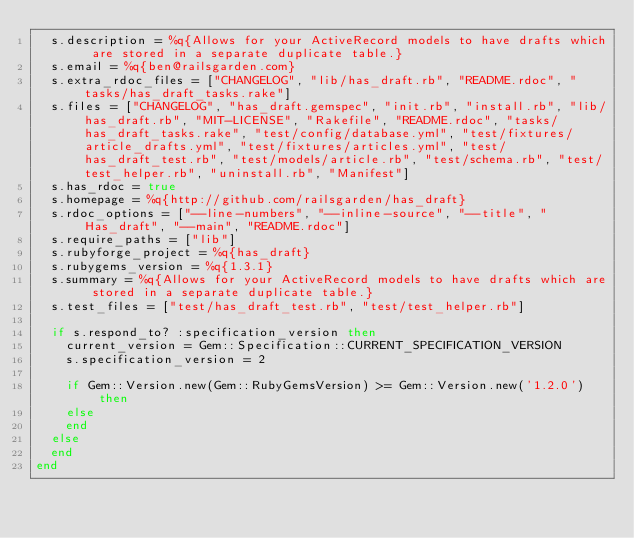<code> <loc_0><loc_0><loc_500><loc_500><_Ruby_>  s.description = %q{Allows for your ActiveRecord models to have drafts which are stored in a separate duplicate table.}
  s.email = %q{ben@railsgarden.com}
  s.extra_rdoc_files = ["CHANGELOG", "lib/has_draft.rb", "README.rdoc", "tasks/has_draft_tasks.rake"]
  s.files = ["CHANGELOG", "has_draft.gemspec", "init.rb", "install.rb", "lib/has_draft.rb", "MIT-LICENSE", "Rakefile", "README.rdoc", "tasks/has_draft_tasks.rake", "test/config/database.yml", "test/fixtures/article_drafts.yml", "test/fixtures/articles.yml", "test/has_draft_test.rb", "test/models/article.rb", "test/schema.rb", "test/test_helper.rb", "uninstall.rb", "Manifest"]
  s.has_rdoc = true
  s.homepage = %q{http://github.com/railsgarden/has_draft}
  s.rdoc_options = ["--line-numbers", "--inline-source", "--title", "Has_draft", "--main", "README.rdoc"]
  s.require_paths = ["lib"]
  s.rubyforge_project = %q{has_draft}
  s.rubygems_version = %q{1.3.1}
  s.summary = %q{Allows for your ActiveRecord models to have drafts which are stored in a separate duplicate table.}
  s.test_files = ["test/has_draft_test.rb", "test/test_helper.rb"]

  if s.respond_to? :specification_version then
    current_version = Gem::Specification::CURRENT_SPECIFICATION_VERSION
    s.specification_version = 2

    if Gem::Version.new(Gem::RubyGemsVersion) >= Gem::Version.new('1.2.0') then
    else
    end
  else
  end
end
</code> 